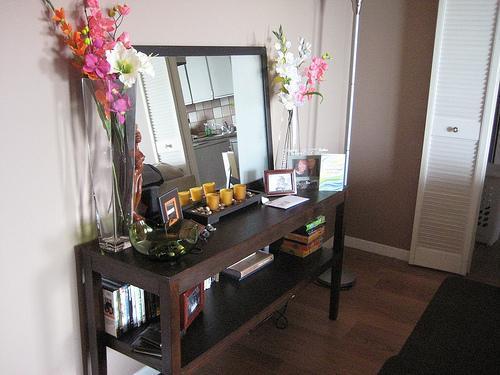How many vases of flowers are there?
Give a very brief answer. 2. 